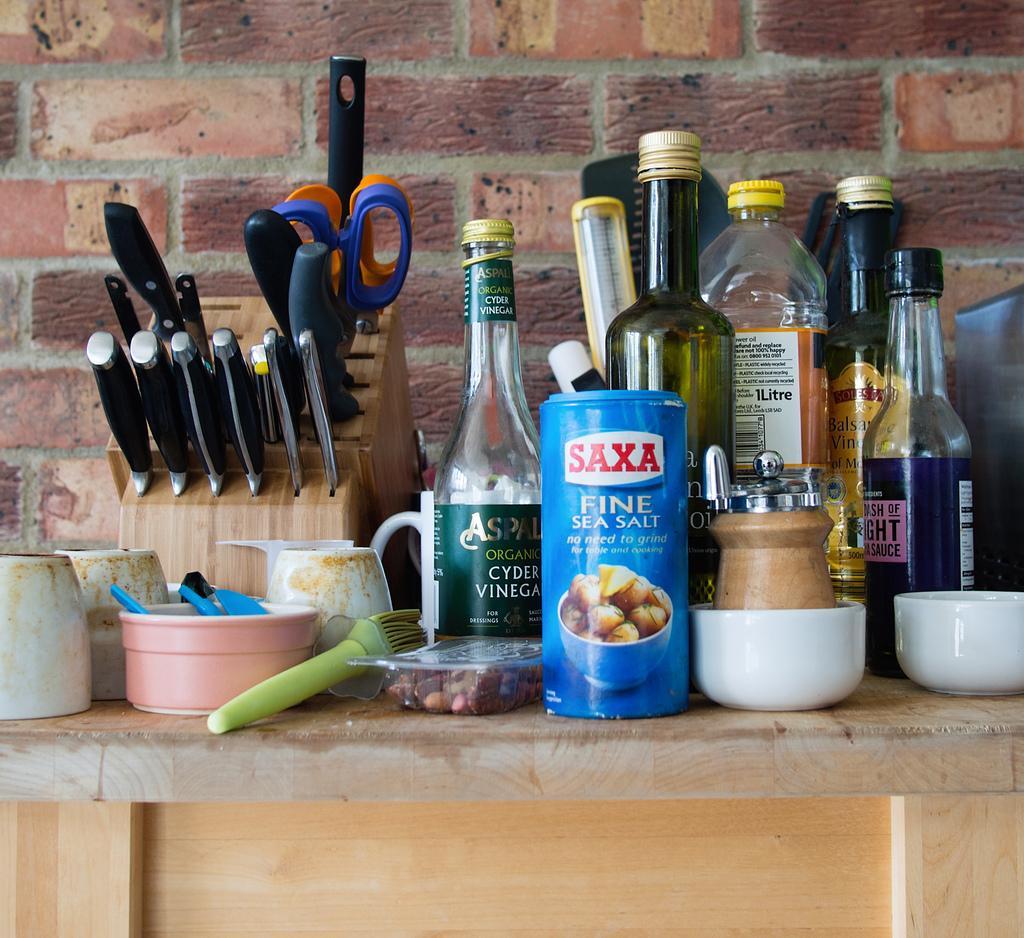Could you give a brief overview of what you see in this image? This picture consist of bottles which are kept on the platform. On the left side there is a knife's stand in which there are knives and scissors. In the background there is a red colour wall. On the platform there are bowls and a brush. 